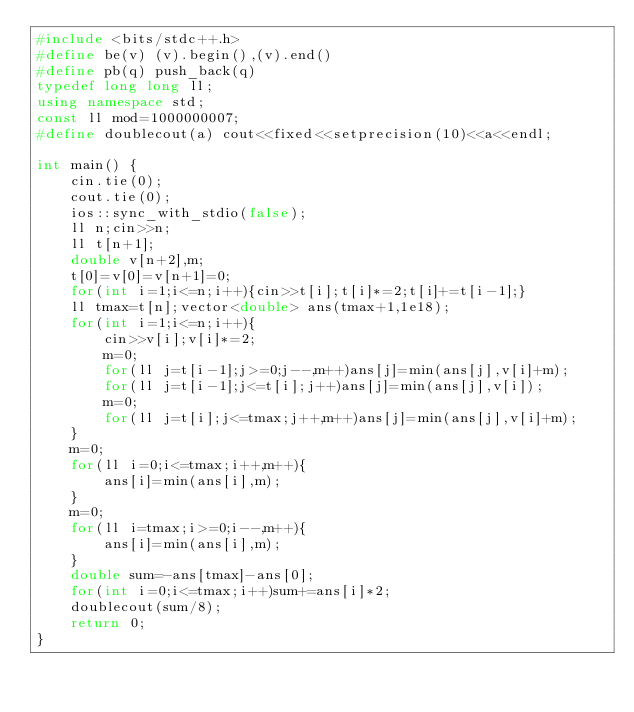Convert code to text. <code><loc_0><loc_0><loc_500><loc_500><_C++_>#include <bits/stdc++.h>
#define be(v) (v).begin(),(v).end()
#define pb(q) push_back(q)
typedef long long ll;
using namespace std;
const ll mod=1000000007;
#define doublecout(a) cout<<fixed<<setprecision(10)<<a<<endl;

int main() {
    cin.tie(0);
    cout.tie(0);
    ios::sync_with_stdio(false);
    ll n;cin>>n;
    ll t[n+1];
    double v[n+2],m;
    t[0]=v[0]=v[n+1]=0;
    for(int i=1;i<=n;i++){cin>>t[i];t[i]*=2;t[i]+=t[i-1];}
    ll tmax=t[n];vector<double> ans(tmax+1,1e18);
    for(int i=1;i<=n;i++){
        cin>>v[i];v[i]*=2;
        m=0;
        for(ll j=t[i-1];j>=0;j--,m++)ans[j]=min(ans[j],v[i]+m);
        for(ll j=t[i-1];j<=t[i];j++)ans[j]=min(ans[j],v[i]);
        m=0;
        for(ll j=t[i];j<=tmax;j++,m++)ans[j]=min(ans[j],v[i]+m);
    }
    m=0;
    for(ll i=0;i<=tmax;i++,m++){
        ans[i]=min(ans[i],m);
    }
    m=0;
    for(ll i=tmax;i>=0;i--,m++){
        ans[i]=min(ans[i],m);
    }
    double sum=-ans[tmax]-ans[0];
    for(int i=0;i<=tmax;i++)sum+=ans[i]*2;
    doublecout(sum/8);
    return 0;
}</code> 